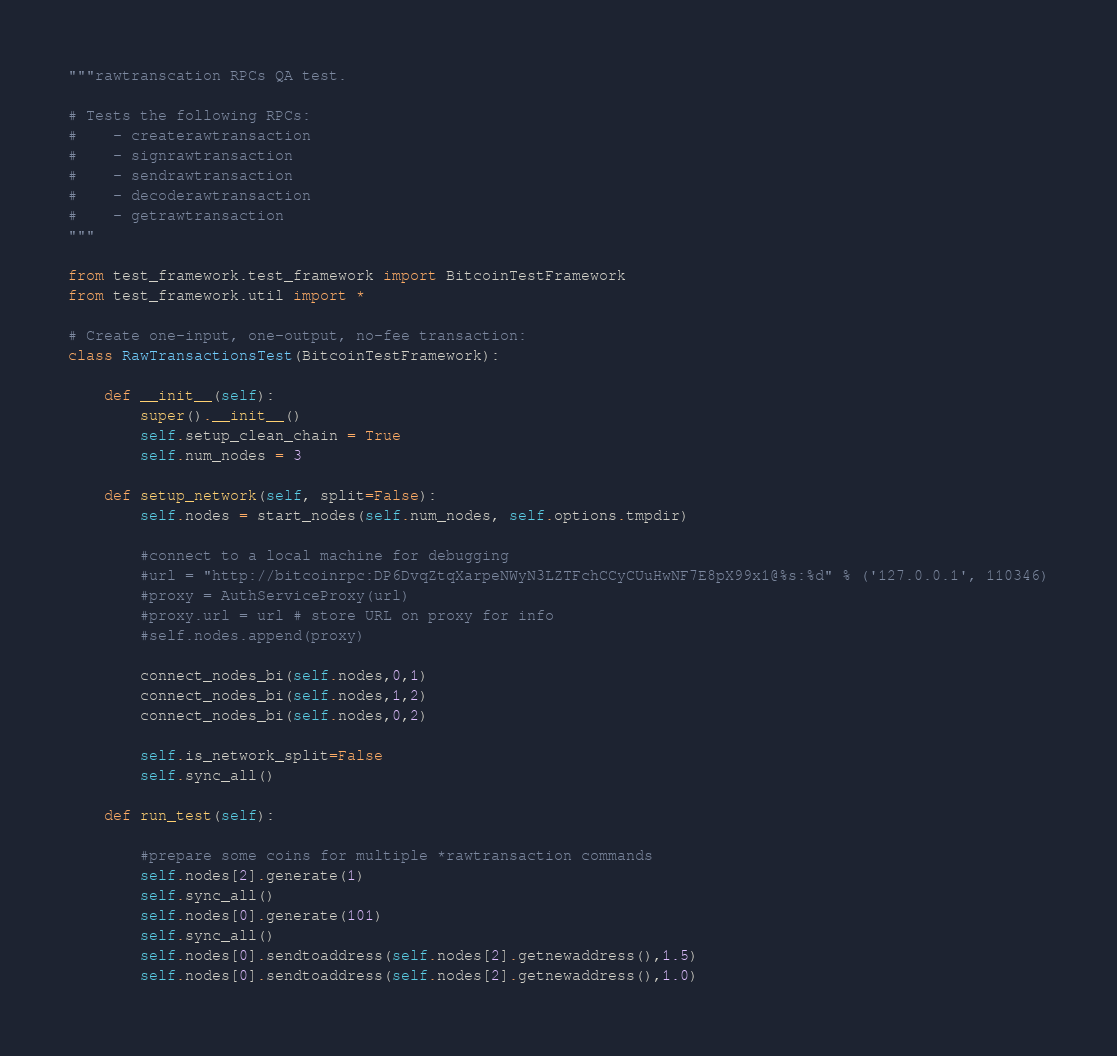Convert code to text. <code><loc_0><loc_0><loc_500><loc_500><_Python_>"""rawtranscation RPCs QA test.

# Tests the following RPCs:
#    - createrawtransaction
#    - signrawtransaction
#    - sendrawtransaction
#    - decoderawtransaction
#    - getrawtransaction
"""

from test_framework.test_framework import BitcoinTestFramework
from test_framework.util import *

# Create one-input, one-output, no-fee transaction:
class RawTransactionsTest(BitcoinTestFramework):

    def __init__(self):
        super().__init__()
        self.setup_clean_chain = True
        self.num_nodes = 3

    def setup_network(self, split=False):
        self.nodes = start_nodes(self.num_nodes, self.options.tmpdir)

        #connect to a local machine for debugging
        #url = "http://bitcoinrpc:DP6DvqZtqXarpeNWyN3LZTFchCCyCUuHwNF7E8pX99x1@%s:%d" % ('127.0.0.1', 110346)
        #proxy = AuthServiceProxy(url)
        #proxy.url = url # store URL on proxy for info
        #self.nodes.append(proxy)

        connect_nodes_bi(self.nodes,0,1)
        connect_nodes_bi(self.nodes,1,2)
        connect_nodes_bi(self.nodes,0,2)

        self.is_network_split=False
        self.sync_all()

    def run_test(self):

        #prepare some coins for multiple *rawtransaction commands
        self.nodes[2].generate(1)
        self.sync_all()
        self.nodes[0].generate(101)
        self.sync_all()
        self.nodes[0].sendtoaddress(self.nodes[2].getnewaddress(),1.5)
        self.nodes[0].sendtoaddress(self.nodes[2].getnewaddress(),1.0)</code> 